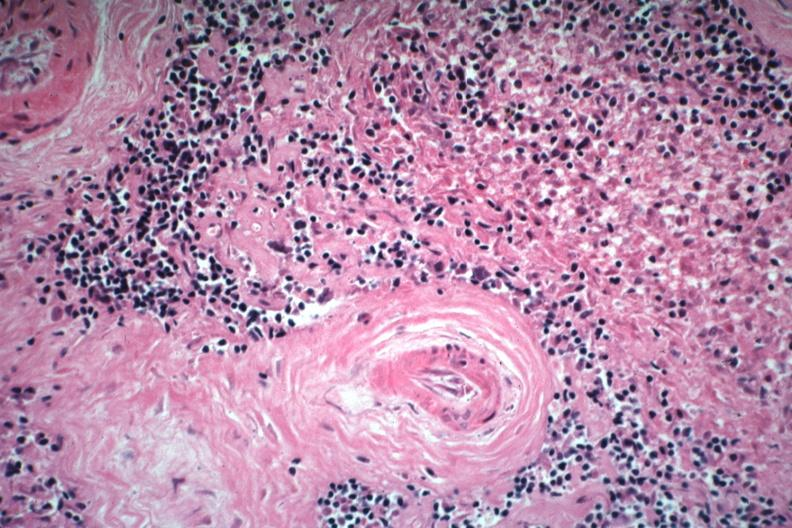what is present?
Answer the question using a single word or phrase. Lupus erythematosus basophilic bodies and periarterial fibrosis 